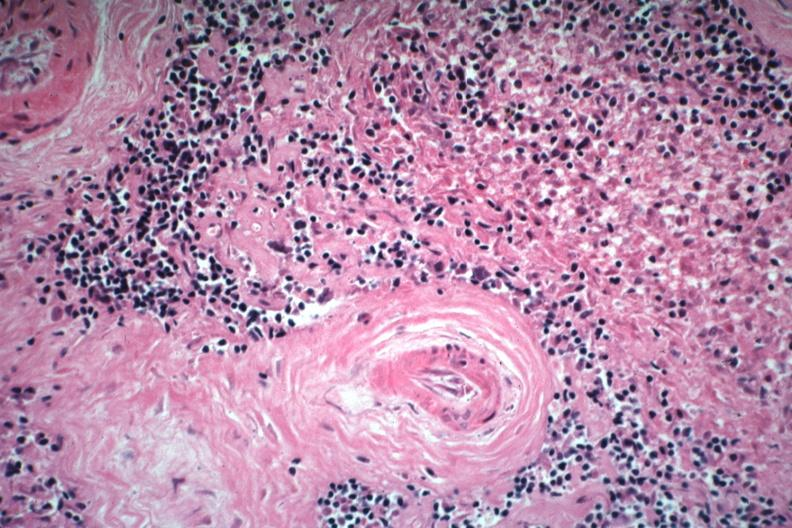what is present?
Answer the question using a single word or phrase. Lupus erythematosus basophilic bodies and periarterial fibrosis 